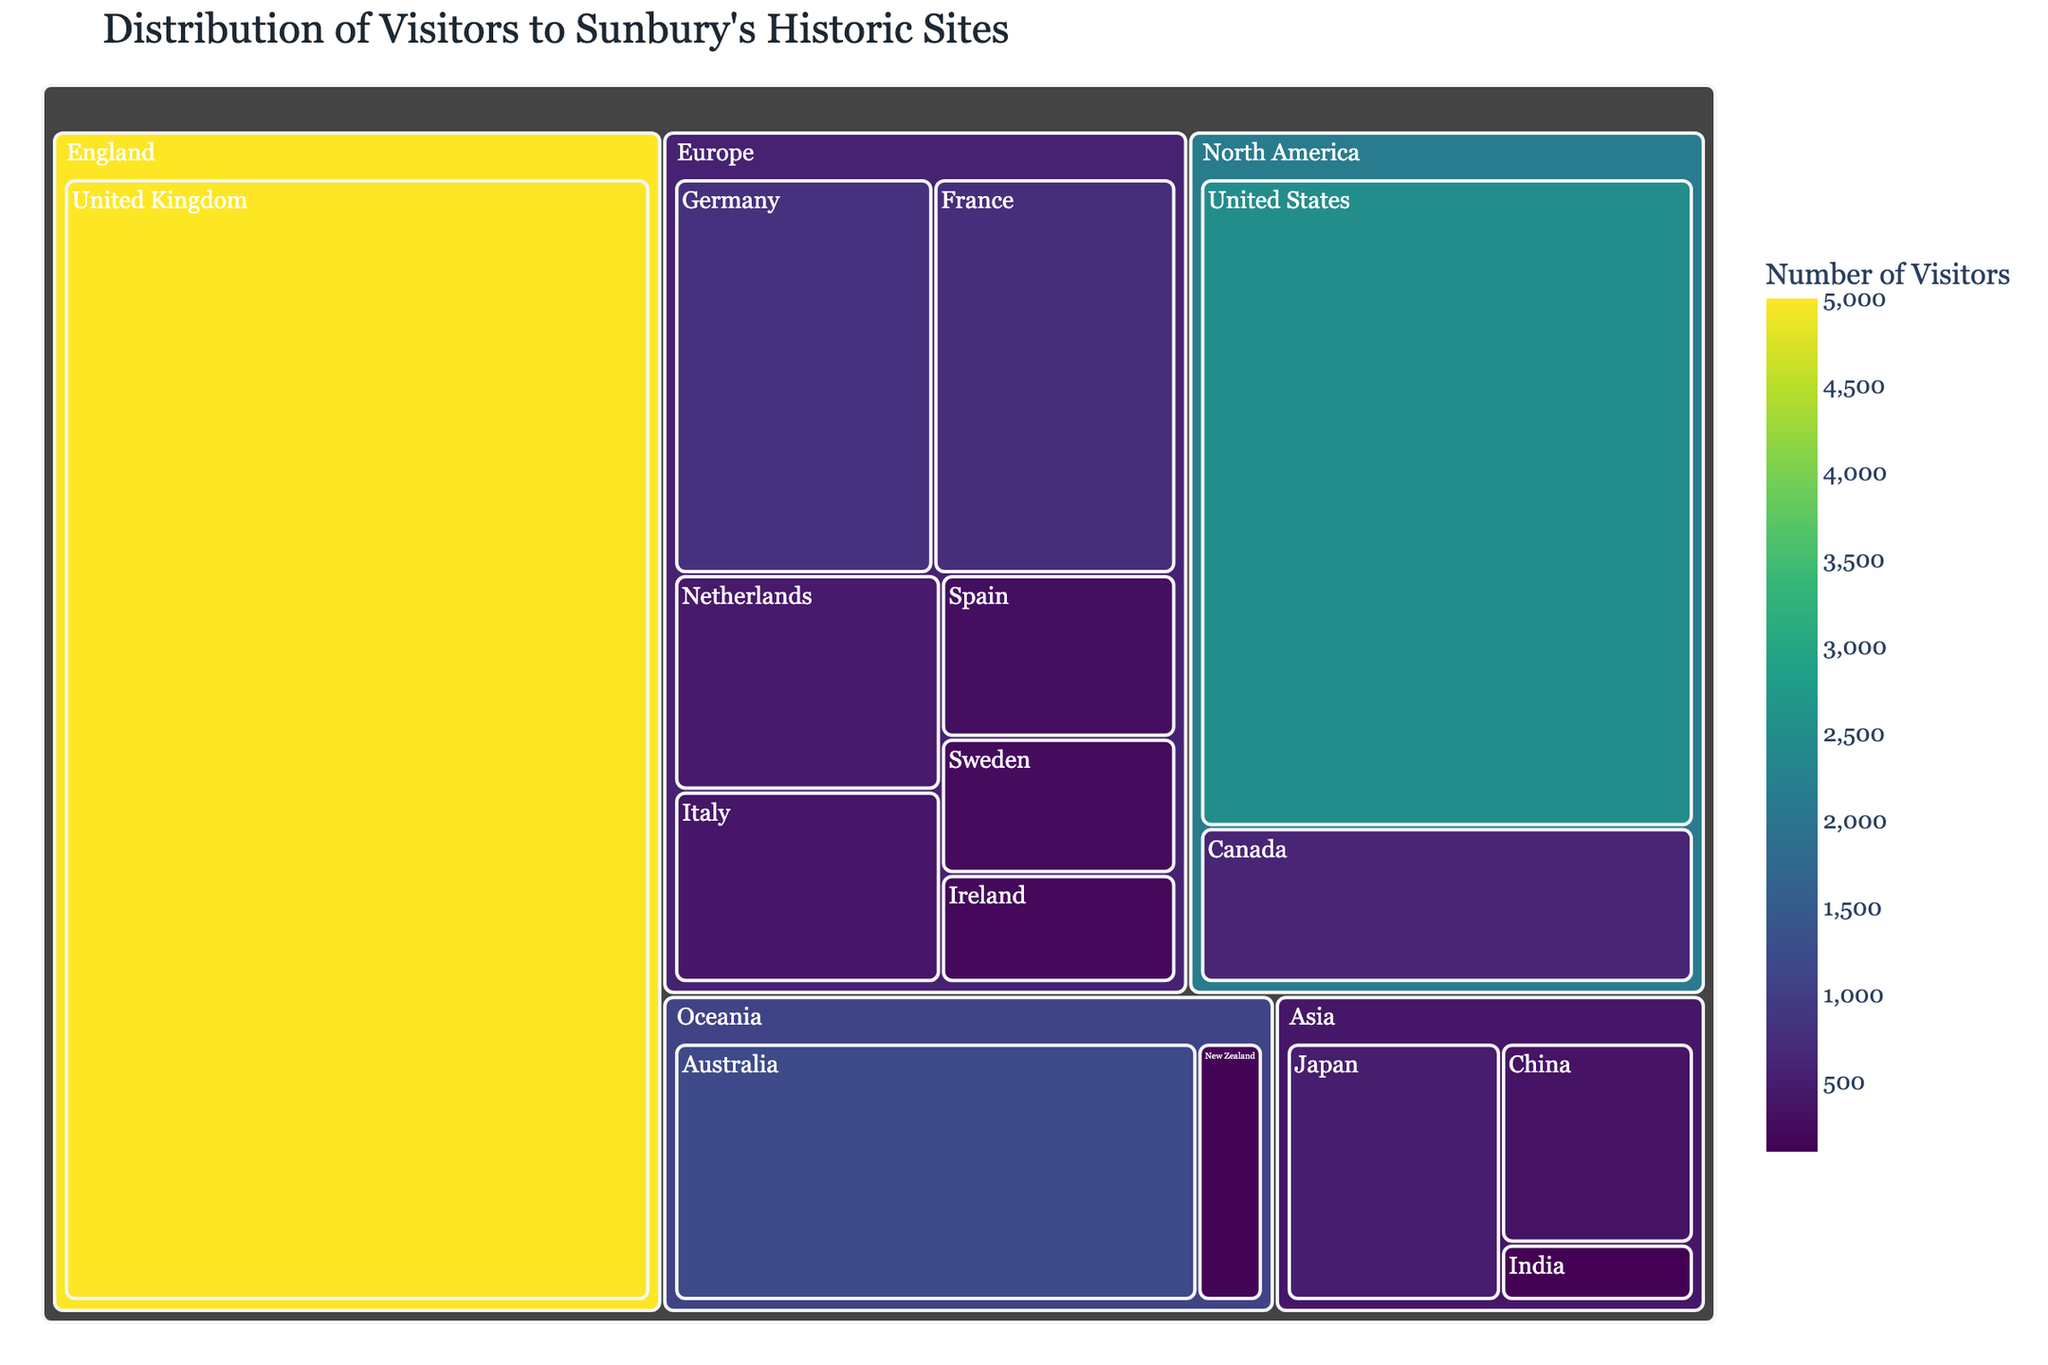What is the total number of visitors from Europe? The countries listed under Europe are Germany, France, Netherlands, Italy, Spain, Sweden, and Ireland. Their respective visitor numbers are 800, 750, 450, 400, 300, 250, and 200. Summing these numbers gives 800 + 750 + 450 + 400 + 300 + 250 + 200 = 3150 visitors.
Answer: 3150 Which country has the most visitors to Sunbury's historic sites? The data shows visitor numbers for each country. The United Kingdom has the highest number with 5000 visitors.
Answer: United Kingdom What is the combined number of visitors from North America? The countries listed under North America are the United States and Canada. Their respective visitor numbers are 2500 and 600. Adding these gives 2500 + 600 = 3100 visitors.
Answer: 3100 How many more visitors are there from the United Kingdom compared to Australia? The United Kingdom has 5000 visitors and Australia has 1200 visitors. The difference is 5000 - 1200 = 3800 visitors.
Answer: 3800 What color represents the highest number of visitors on the treemap? The treemap uses a color continuous scale where the highest values correspond to the darkest shade of the Viridis scale. This color represents the largest number of visitors.
Answer: Darkest shade of Viridis Which region has the least representation in terms of the number of countries and what are they? Oceania has the least number of countries represented, which are Australia and New Zealand.
Answer: Oceania; Australia, New Zealand Are there more visitors from Asia or Oceania? Adding the visitor numbers from Asia (Japan: 500, China: 350, India: 100) gives 500 + 350 + 100 = 950. For Oceania (Australia: 1200, New Zealand: 150) it’s 1200 + 150 = 1350. Oceania has more visitors.
Answer: Oceania What is the average number of visitors per country from Europe? The total number of visitors from Europe is 3150, and there are 7 countries in Europe. The average is 3150 / 7 ≈ 450 visitors per country.
Answer: 450 Which country from Asia has the least number of visitors? The countries listed under Asia are Japan (500), China (350), and India (100). Among these, India has the least with 100 visitors.
Answer: India What is the total number of visitors to Sunbury's historic sites? Summing visitor numbers for all the countries: 5000 (UK) + 2500 (US) + 1200 (Australia) + 800 (Germany) + 750 (France) + 600 (Canada) + 500 (Japan) + 450 (Netherlands) + 400 (Italy) + 350 (China) + 300 (Spain) + 250 (Sweden) + 200 (Ireland) + 150 (New Zealand) + 100 (India) = 14550 visitors.
Answer: 14550 